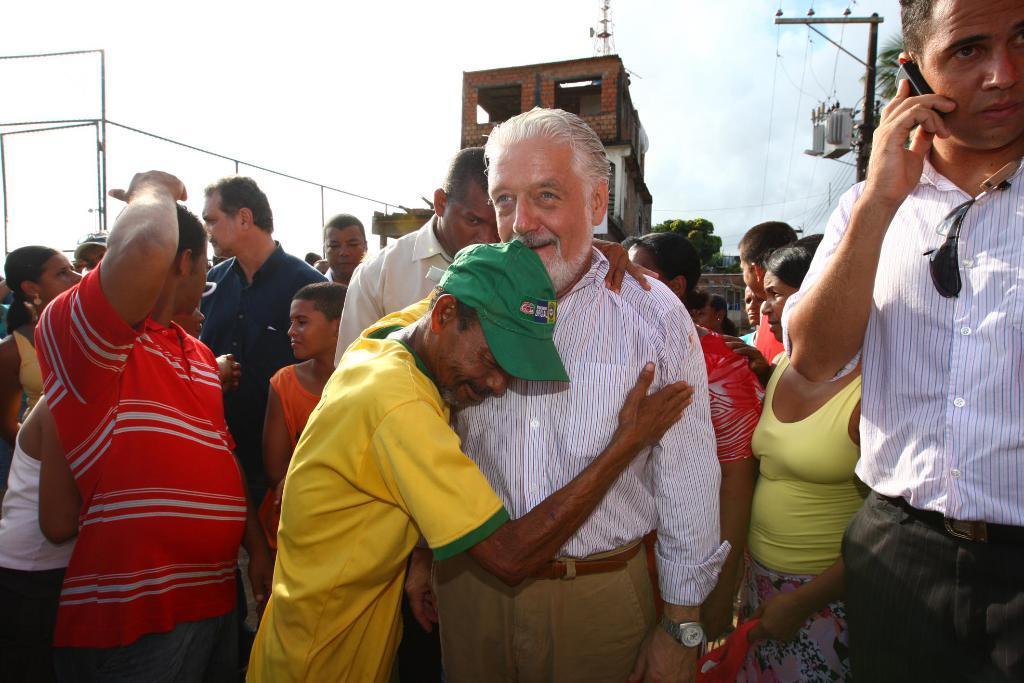Could you give a brief overview of what you see in this image? This is an outside view. At the bottom, I can see a crowd of people standing. On the right side there is a man holding a mobile in the hand. In the middle of the image there is a person hugging another man and both are smiling. In the background there is a building, trees and also I can see few poles. At the top of the image I can see the sky. 